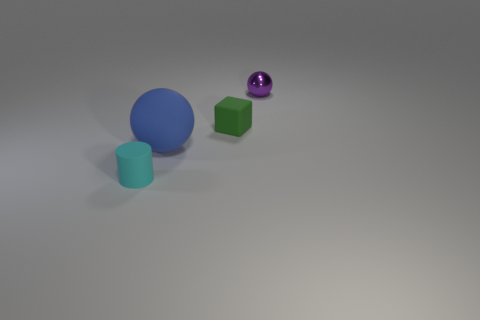Add 3 gray cylinders. How many objects exist? 7 Subtract all blue spheres. How many spheres are left? 1 Subtract 0 yellow cylinders. How many objects are left? 4 Subtract all cubes. How many objects are left? 3 Subtract all green cylinders. Subtract all red balls. How many cylinders are left? 1 Subtract all green cubes. How many blue spheres are left? 1 Subtract all purple spheres. Subtract all small cyan rubber objects. How many objects are left? 2 Add 4 tiny matte blocks. How many tiny matte blocks are left? 5 Add 4 large matte things. How many large matte things exist? 5 